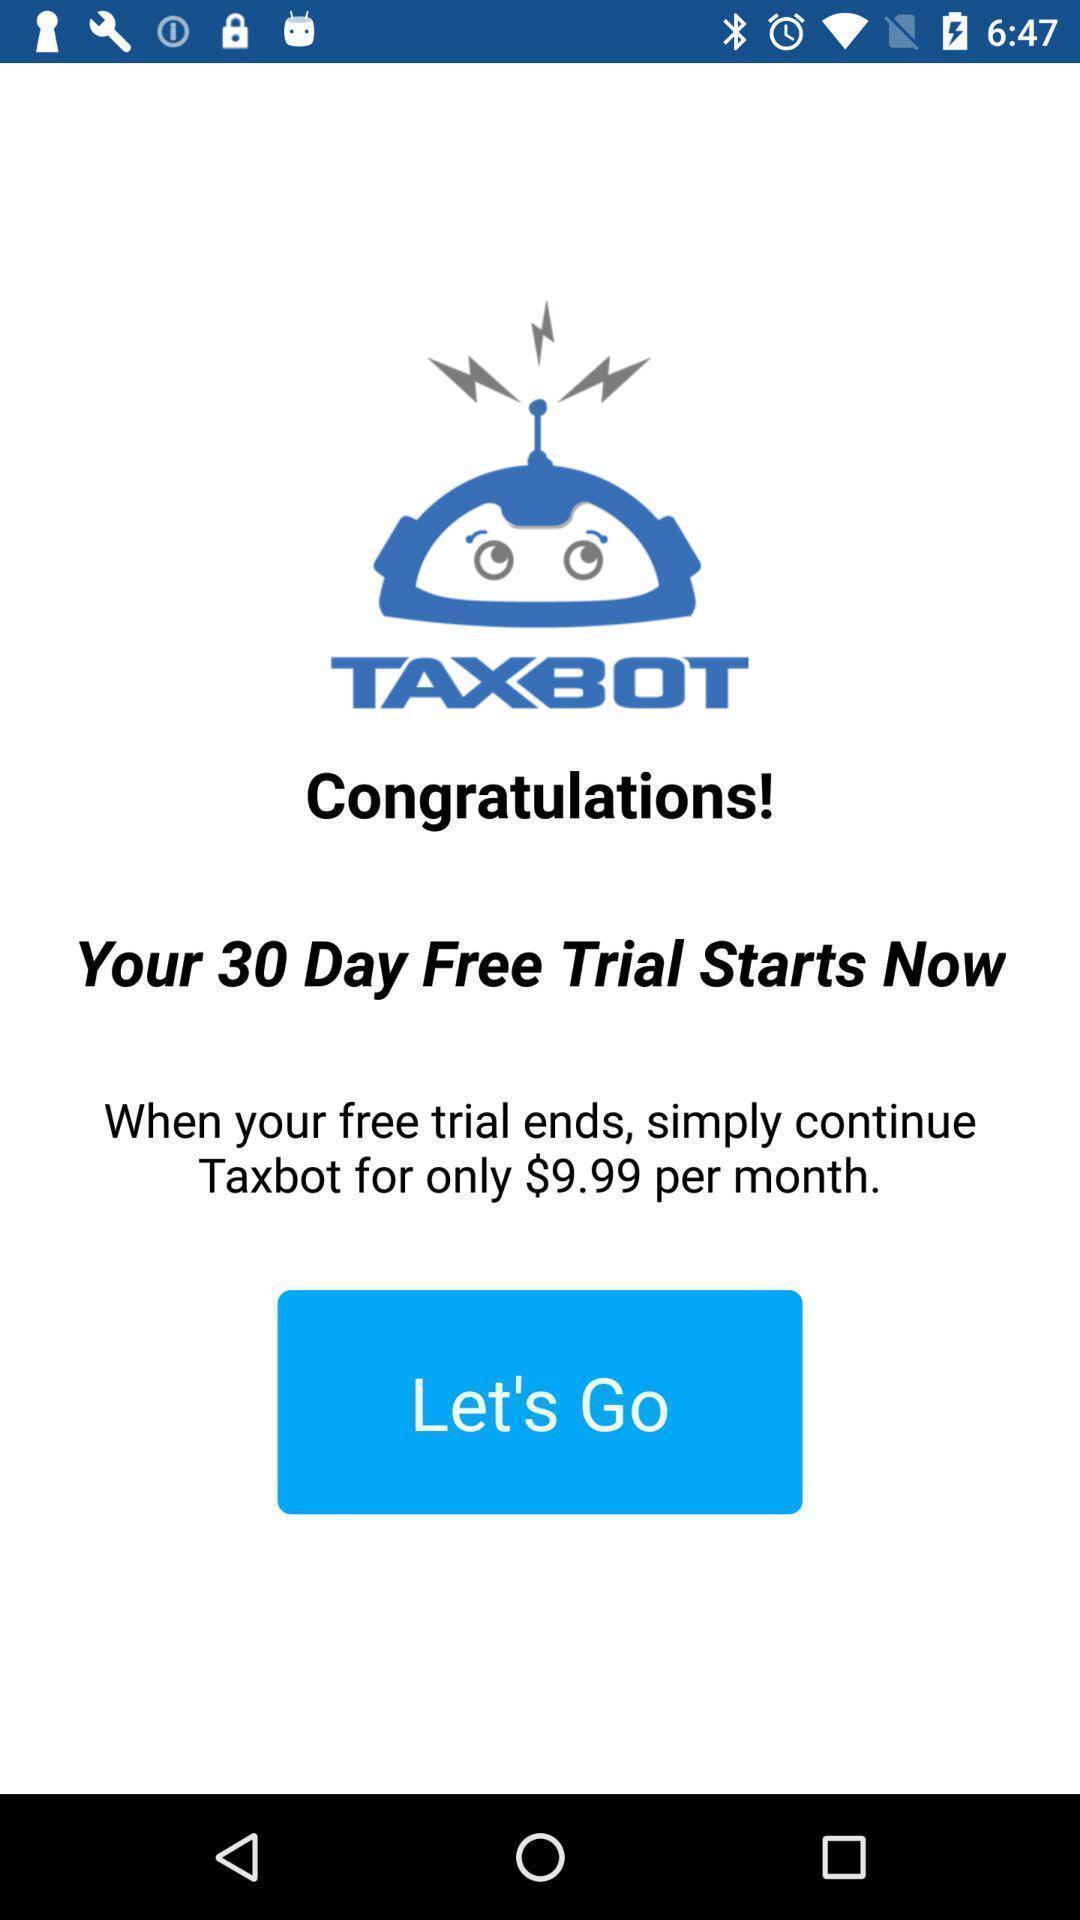Give me a summary of this screen capture. Welcome page of mileage calculator. 